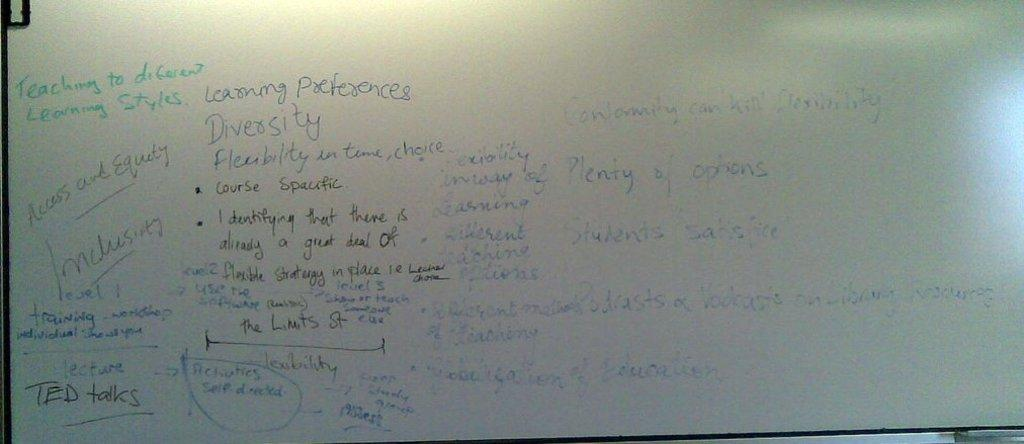<image>
Share a concise interpretation of the image provided. A whiteboard has a green note that says "teaching to different learning styles". 